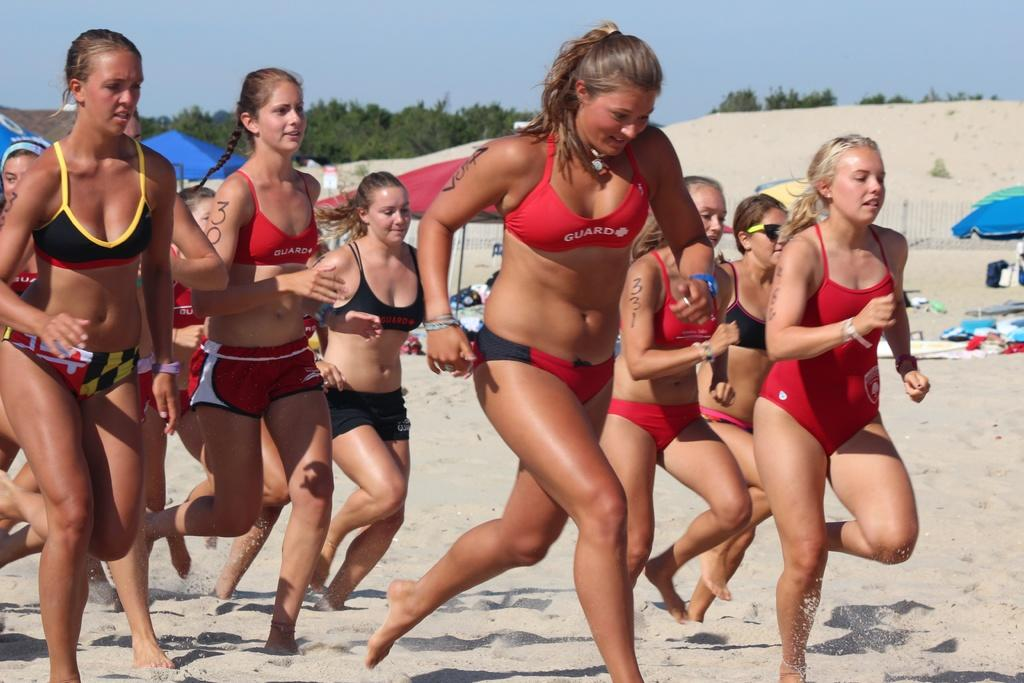<image>
Render a clear and concise summary of the photo. Women wearing Guard swimsuits are running down the beach. 